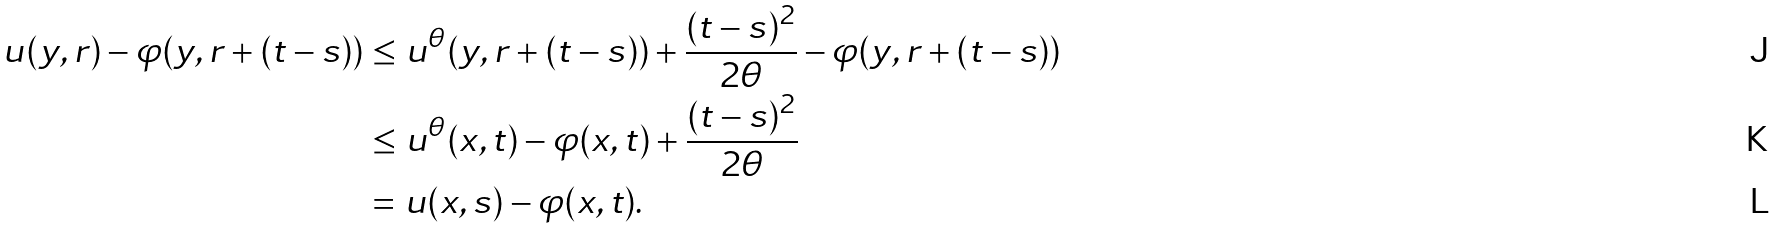<formula> <loc_0><loc_0><loc_500><loc_500>u ( y , r ) - \varphi ( y , r + ( t - s ) ) & \leq u ^ { \theta } ( y , r + ( t - s ) ) + \frac { ( t - s ) ^ { 2 } } { 2 \theta } - \varphi ( y , r + ( t - s ) ) \\ & \leq u ^ { \theta } ( x , t ) - \varphi ( x , t ) + \frac { ( t - s ) ^ { 2 } } { 2 \theta } \\ & = u ( x , s ) - \varphi ( x , t ) .</formula> 